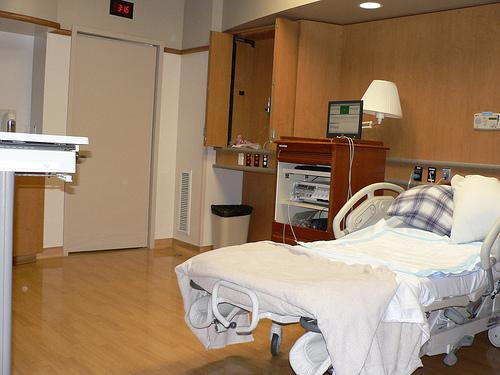Question: what pattern is the pillow case?
Choices:
A. Polka dots.
B. Plaid.
C. Stripes.
D. Solid.
Answer with the letter. Answer: B Question: how is the floor made?
Choices:
A. Of wood.
B. Carpet.
C. Tile.
D. Linoleum.
Answer with the letter. Answer: A Question: what color is the bed linen?
Choices:
A. White.
B. Black.
C. Red.
D. Blue.
Answer with the letter. Answer: A Question: what are the cabinets made of?
Choices:
A. Oak.
B. Plastic.
C. Tile.
D. Wood.
Answer with the letter. Answer: D Question: what color are the walls?
Choices:
A. Oak.
B. Brown.
C. Cream.
D. Maple.
Answer with the letter. Answer: A Question: who would stay here?
Choices:
A. A little girl.
B. A baby.
C. A little boy.
D. A patient.
Answer with the letter. Answer: D 